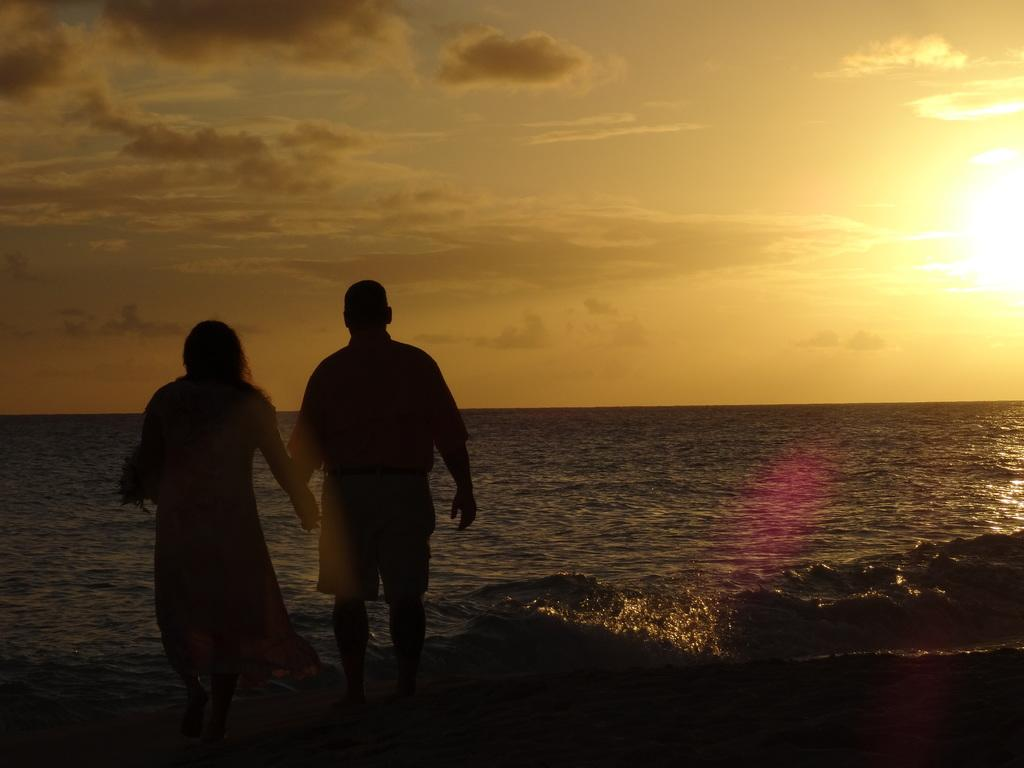How many people are present in the image? There is a man and a woman in the image. What can be seen in the background of the image? Water and the sky are visible in the background of the image. What is the condition of the sky in the image? Clouds are present in the sky. What note is the man playing on his orange instrument in the image? There is no instrument, let alone an orange one, present in the image. 